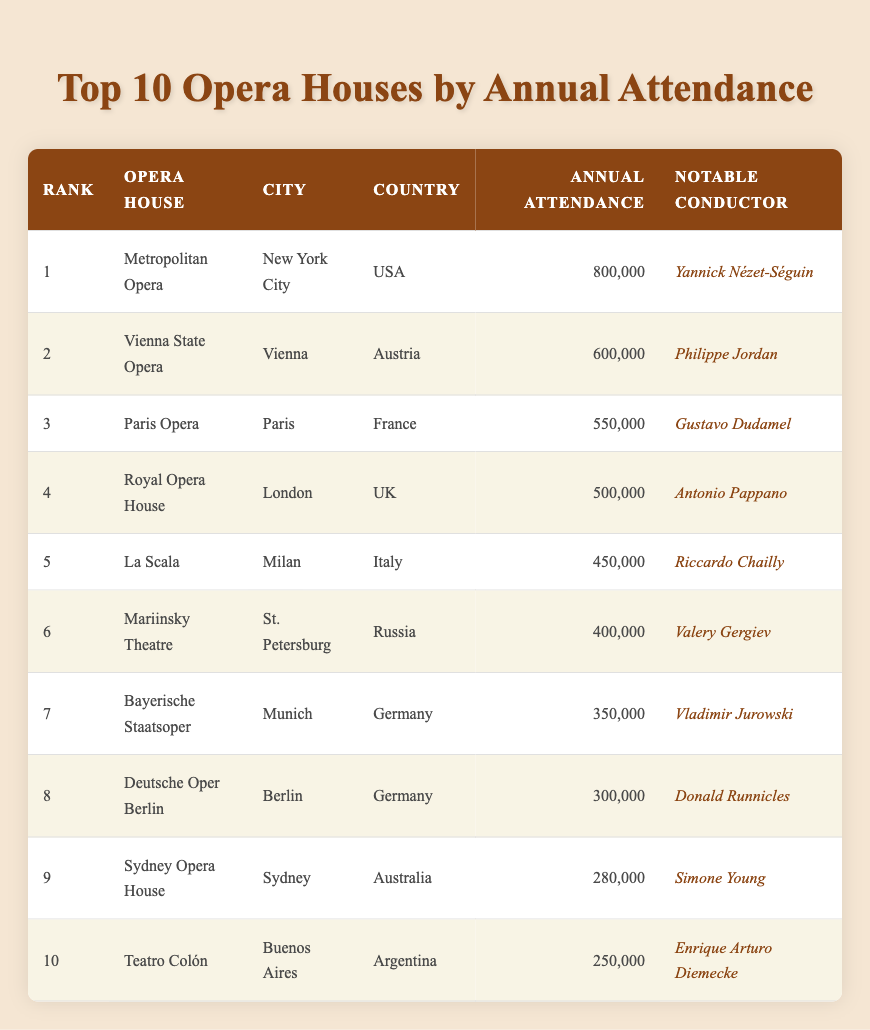What opera house has the highest annual attendance? The table ranks opera houses by their annual attendance, and the Metropolitan Opera is listed at rank 1 with an attendance of 800,000.
Answer: Metropolitan Opera Which city is home to La Scala? The table shows that La Scala is located in Milan, as indicated in the City column for that opera house.
Answer: Milan How many more attendees does the Vienna State Opera have compared to the Sydney Opera House? The Vienna State Opera has an annual attendance of 600,000 and the Sydney Opera House has 280,000. Calculating the difference: 600,000 - 280,000 equals 320,000.
Answer: 320,000 Is Gustavo Dudamel the notable conductor for the Royal Opera House? The table lists Gustavo Dudamel as the notable conductor for the Paris Opera, not the Royal Opera House, where Antonio Pappano is noted as the conductor. Therefore, the answer is no.
Answer: No What is the total annual attendance of the top three opera houses? The total attendance for the top three (Metropolitan Opera, Vienna State Opera, and Paris Opera) is calculated as follows: 800,000 (Metropolitan) + 600,000 (Vienna) + 550,000 (Paris) equals 1,950,000.
Answer: 1,950,000 Which country has the most opera houses in the top 10? By examining the Country column, we see that Germany has two opera houses (Bayerische Staatsoper and Deutsche Oper Berlin) listed in the top 10, more than any other country.
Answer: Germany What is the average annual attendance of the opera houses located in Italy? Italy has one opera house listed, La Scala with an attendance of 450,000. Since it’s the only one, the average is simply the same as its attendance, which is 450,000.
Answer: 450,000 Which notable conductor is associated with the lowest-ranking opera house on the list? The Teatro Colón is ranked 10th and has an annual attendance of 250,000. The notable conductor associated with it is Enrique Arturo Diemecke.
Answer: Enrique Arturo Diemecke 